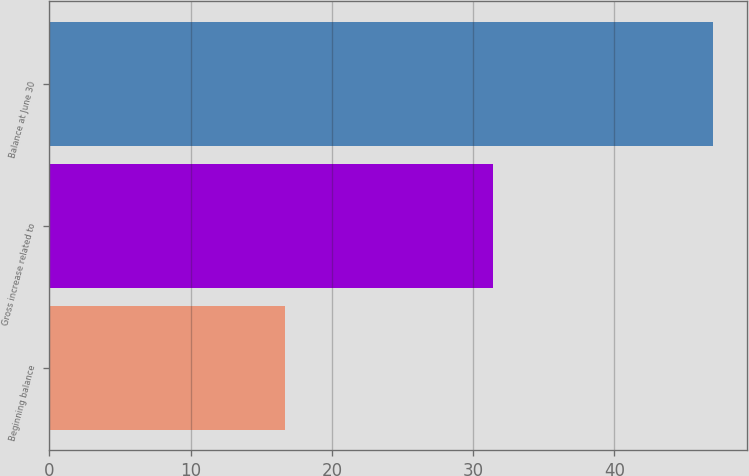<chart> <loc_0><loc_0><loc_500><loc_500><bar_chart><fcel>Beginning balance<fcel>Gross increase related to<fcel>Balance at June 30<nl><fcel>16.7<fcel>31.4<fcel>47<nl></chart> 